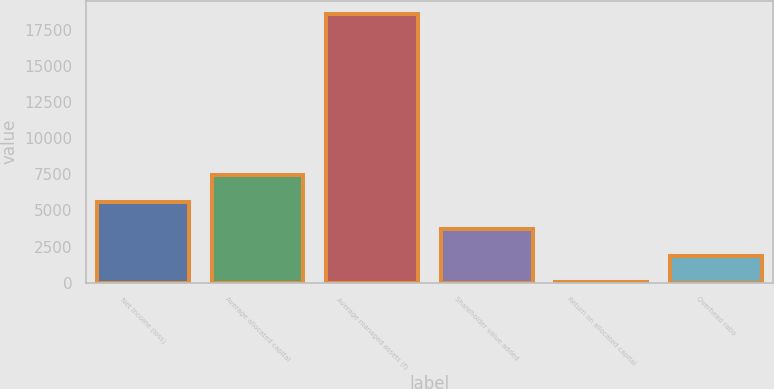<chart> <loc_0><loc_0><loc_500><loc_500><bar_chart><fcel>Net income (loss)<fcel>Average allocated capital<fcel>Average managed assets (f)<fcel>Shareholder value added<fcel>Return on allocated capital<fcel>Overhead ratio<nl><fcel>5580.3<fcel>7433.4<fcel>18552<fcel>3727.2<fcel>21<fcel>1874.1<nl></chart> 